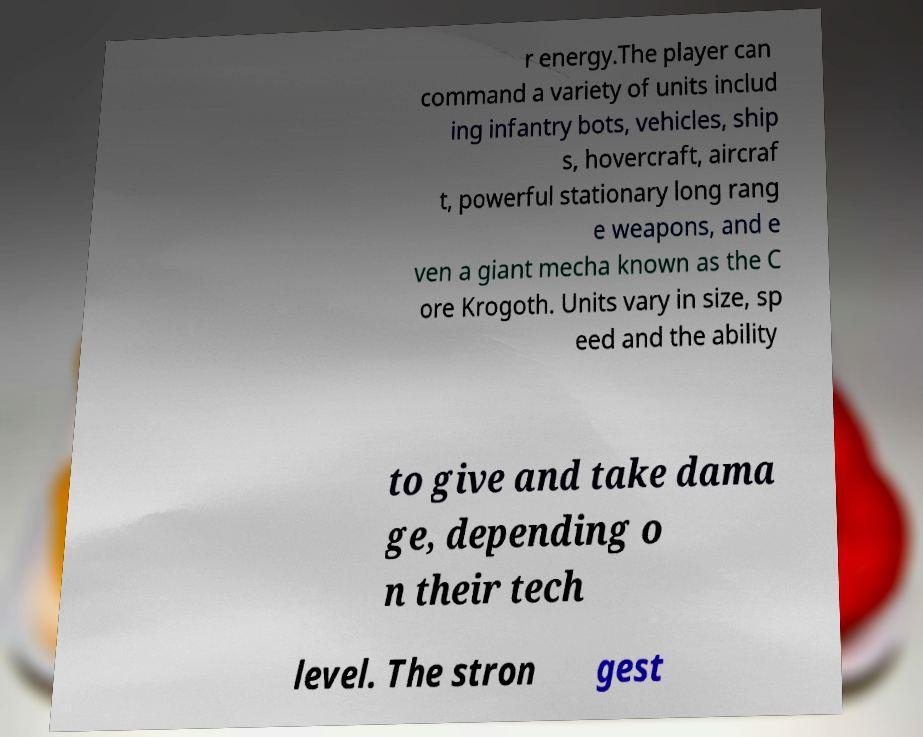Could you assist in decoding the text presented in this image and type it out clearly? r energy.The player can command a variety of units includ ing infantry bots, vehicles, ship s, hovercraft, aircraf t, powerful stationary long rang e weapons, and e ven a giant mecha known as the C ore Krogoth. Units vary in size, sp eed and the ability to give and take dama ge, depending o n their tech level. The stron gest 